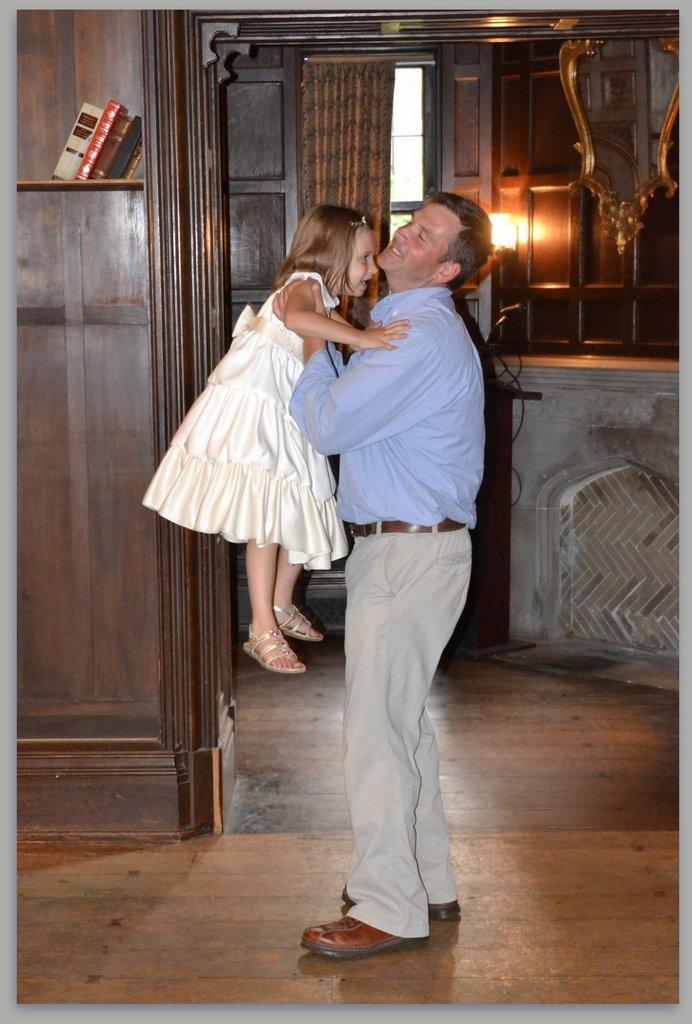Describe this image in one or two sentences. In this image we can see a man. He is wearing blue shirt, pant and carrying girl in his hand. Girl is wearing white color dress. Background of the image wooden wall, door and window is there. We can see one curtain and mirror. Top left of the image books are arranged in rack. 